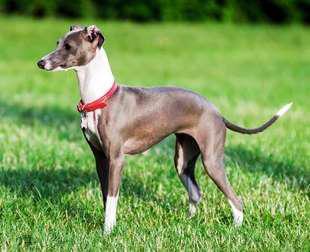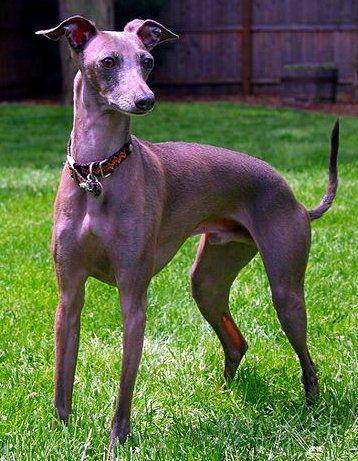The first image is the image on the left, the second image is the image on the right. Considering the images on both sides, is "There is a dog with its head to the left and its tail to the right." valid? Answer yes or no. Yes. 